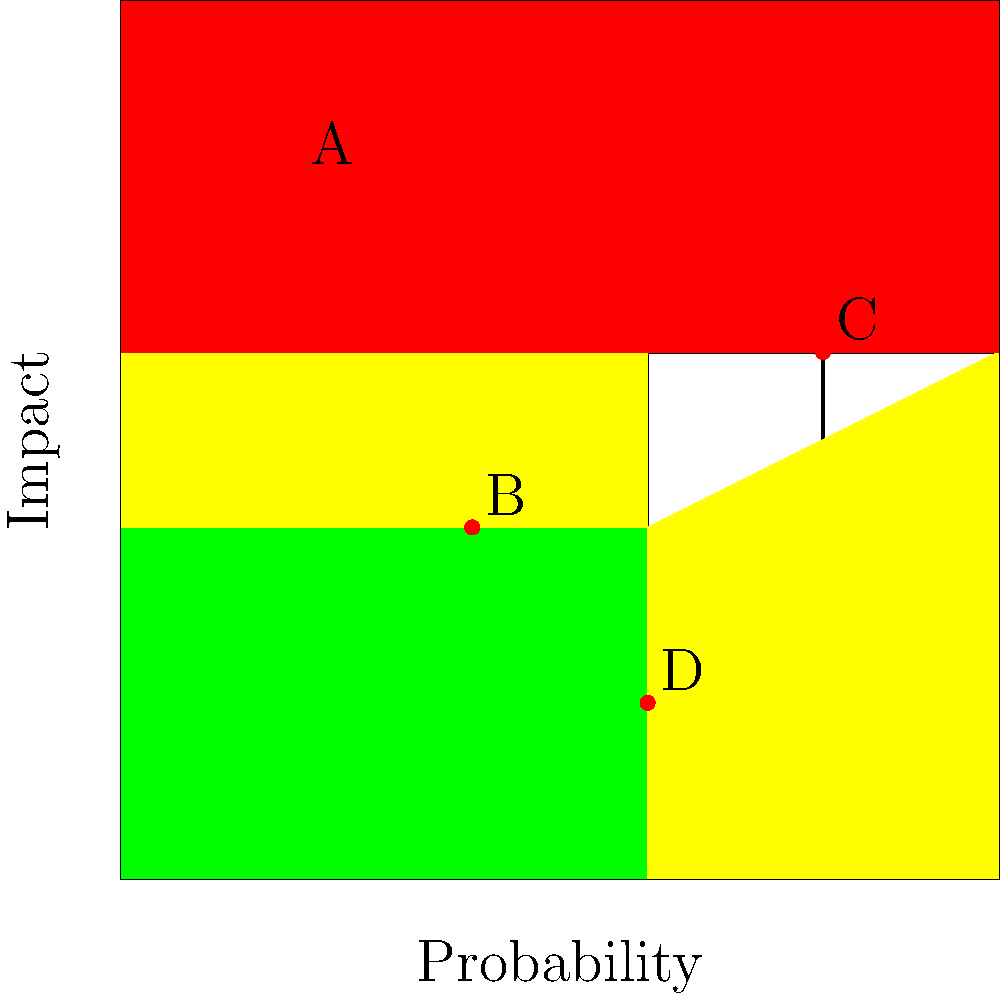As a project manager, you're reviewing the risk matrix for your current project. Based on the matrix shown, which risk should be prioritized first for mitigation strategies? To determine which risk should be prioritized first, we need to analyze the risk matrix provided. The matrix shows the relationship between probability (x-axis) and impact (y-axis) of potential risks. The colors in the matrix represent different risk levels:

1. Green: Low risk
2. Yellow: Medium risk
3. Red: High risk

The risks are plotted on the matrix as follows:
- Risk A: (1, 4)
- Risk B: (2, 2)
- Risk C: (4, 3)
- Risk D: (3, 1)

To prioritize risks, we should consider:
1. The risk level (color zone)
2. The position within the same risk level

Step 1: Identify risks in the highest risk level (red zone)
Risks A and C are in the red zone, indicating high risk.

Step 2: Compare the positions of high-risk items
Between A and C:
- Risk A has a lower probability but higher impact
- Risk C has a higher probability but slightly lower impact

Step 3: Determine which factor is more critical
As a project manager relying on the team leader for well-defined requirements, we should prioritize the risk with the highest impact, as it could significantly affect the project's success.

Therefore, Risk A should be prioritized first for mitigation strategies due to its highest impact, despite its lower probability.
Answer: Risk A 